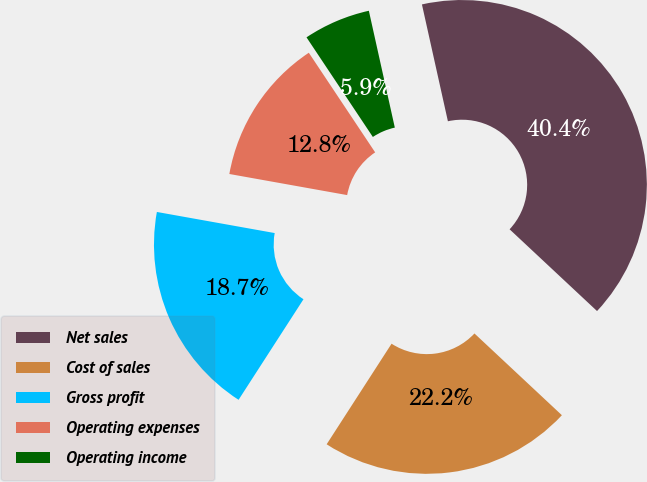Convert chart. <chart><loc_0><loc_0><loc_500><loc_500><pie_chart><fcel>Net sales<fcel>Cost of sales<fcel>Gross profit<fcel>Operating expenses<fcel>Operating income<nl><fcel>40.45%<fcel>22.16%<fcel>18.7%<fcel>12.83%<fcel>5.87%<nl></chart> 